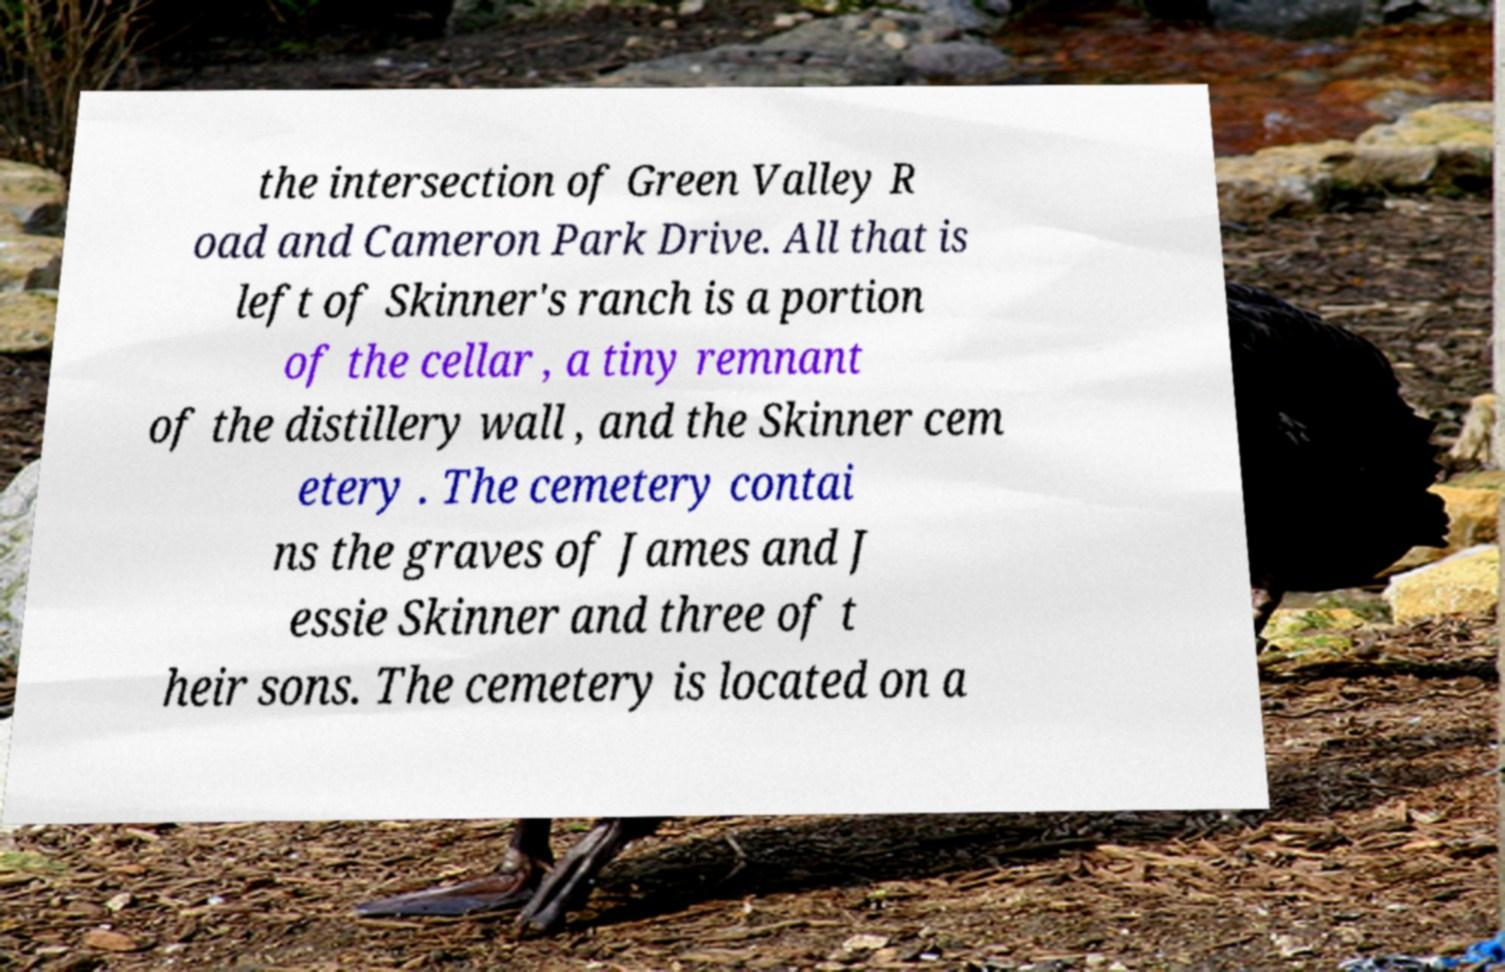For documentation purposes, I need the text within this image transcribed. Could you provide that? the intersection of Green Valley R oad and Cameron Park Drive. All that is left of Skinner's ranch is a portion of the cellar , a tiny remnant of the distillery wall , and the Skinner cem etery . The cemetery contai ns the graves of James and J essie Skinner and three of t heir sons. The cemetery is located on a 